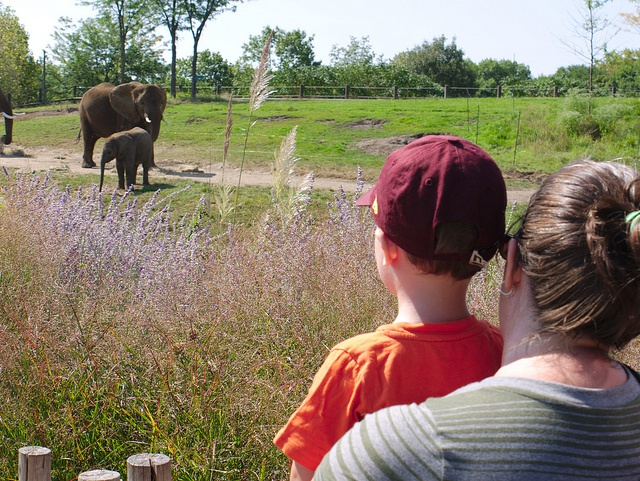Describe the objects in this image and their specific colors. I can see people in white, black, gray, darkgray, and lightgray tones, people in white, black, brown, and maroon tones, elephant in white, black, and gray tones, elephant in white, black, gray, tan, and darkgray tones, and elephant in white, black, darkgray, and gray tones in this image. 